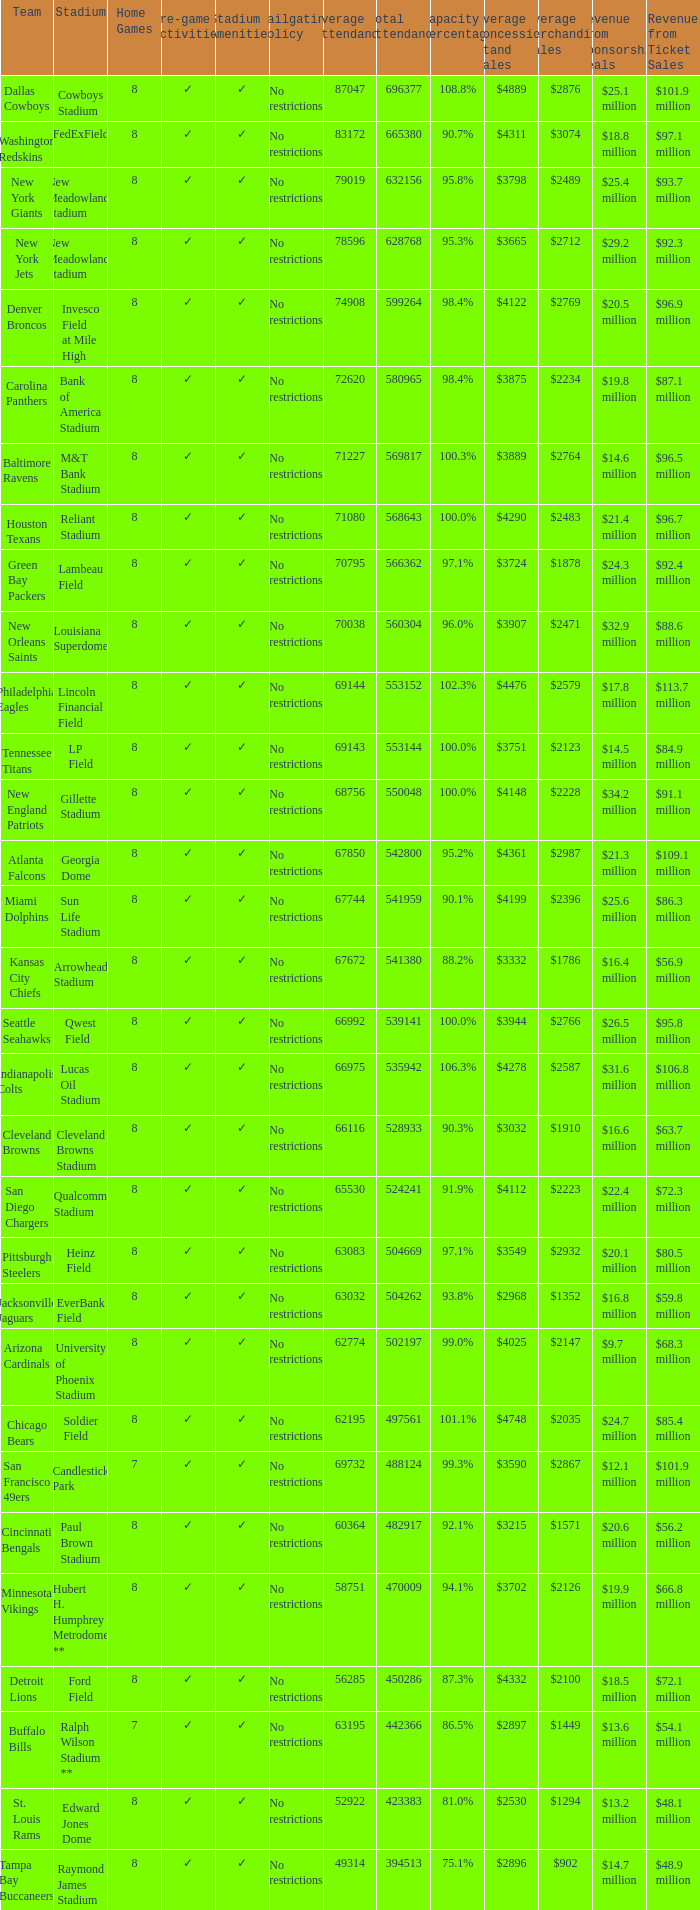What team had a capacity of 102.3%? Philadelphia Eagles. 